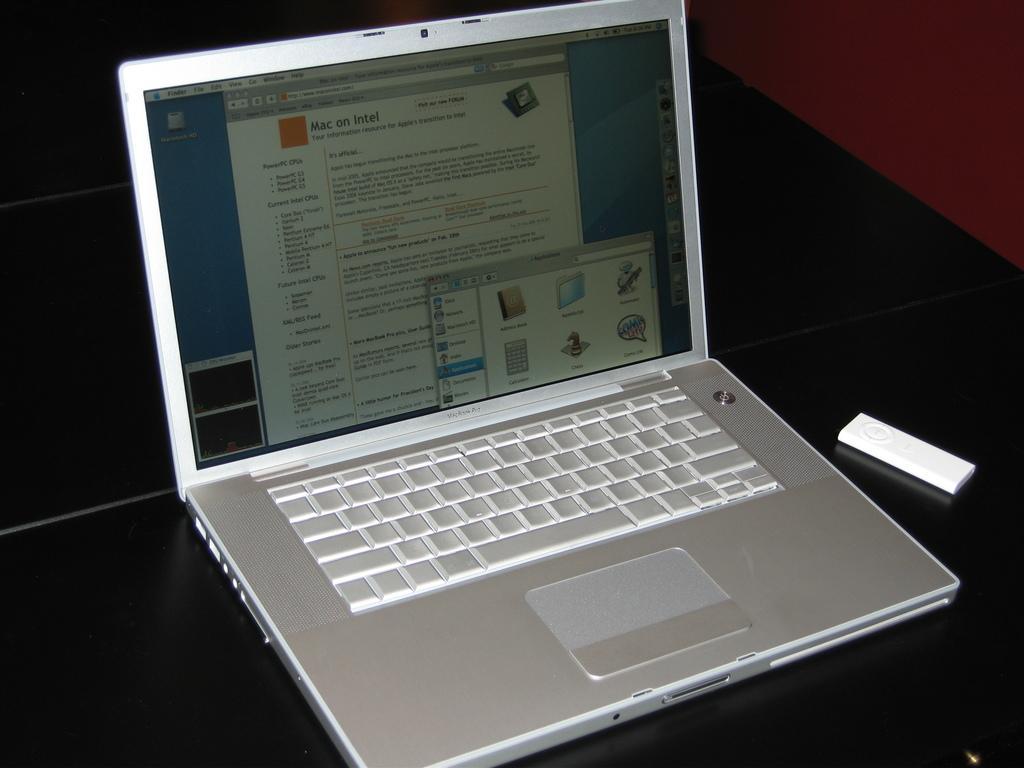In one or two sentences, can you explain what this image depicts? In this image I can see a laptop, a white colour thing and on this screen I can see something is written. 